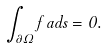Convert formula to latex. <formula><loc_0><loc_0><loc_500><loc_500>\int _ { \partial \Omega } f \, a d s = 0 .</formula> 